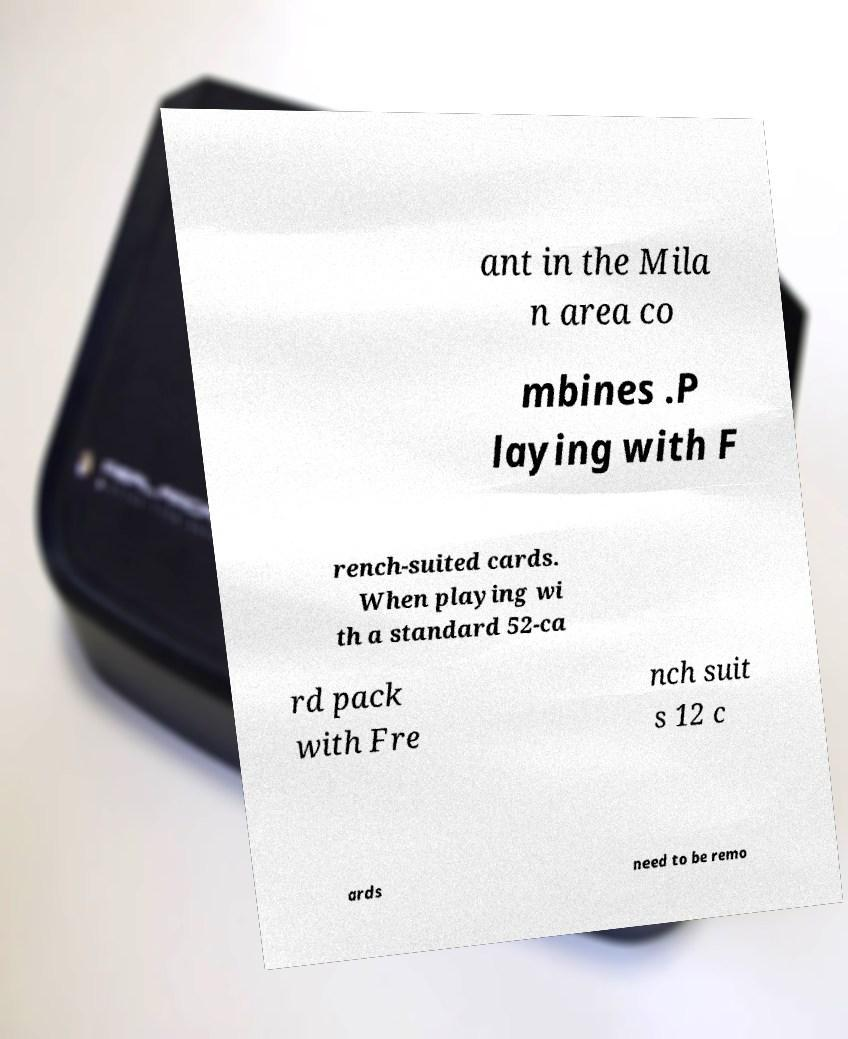Please identify and transcribe the text found in this image. ant in the Mila n area co mbines .P laying with F rench-suited cards. When playing wi th a standard 52-ca rd pack with Fre nch suit s 12 c ards need to be remo 